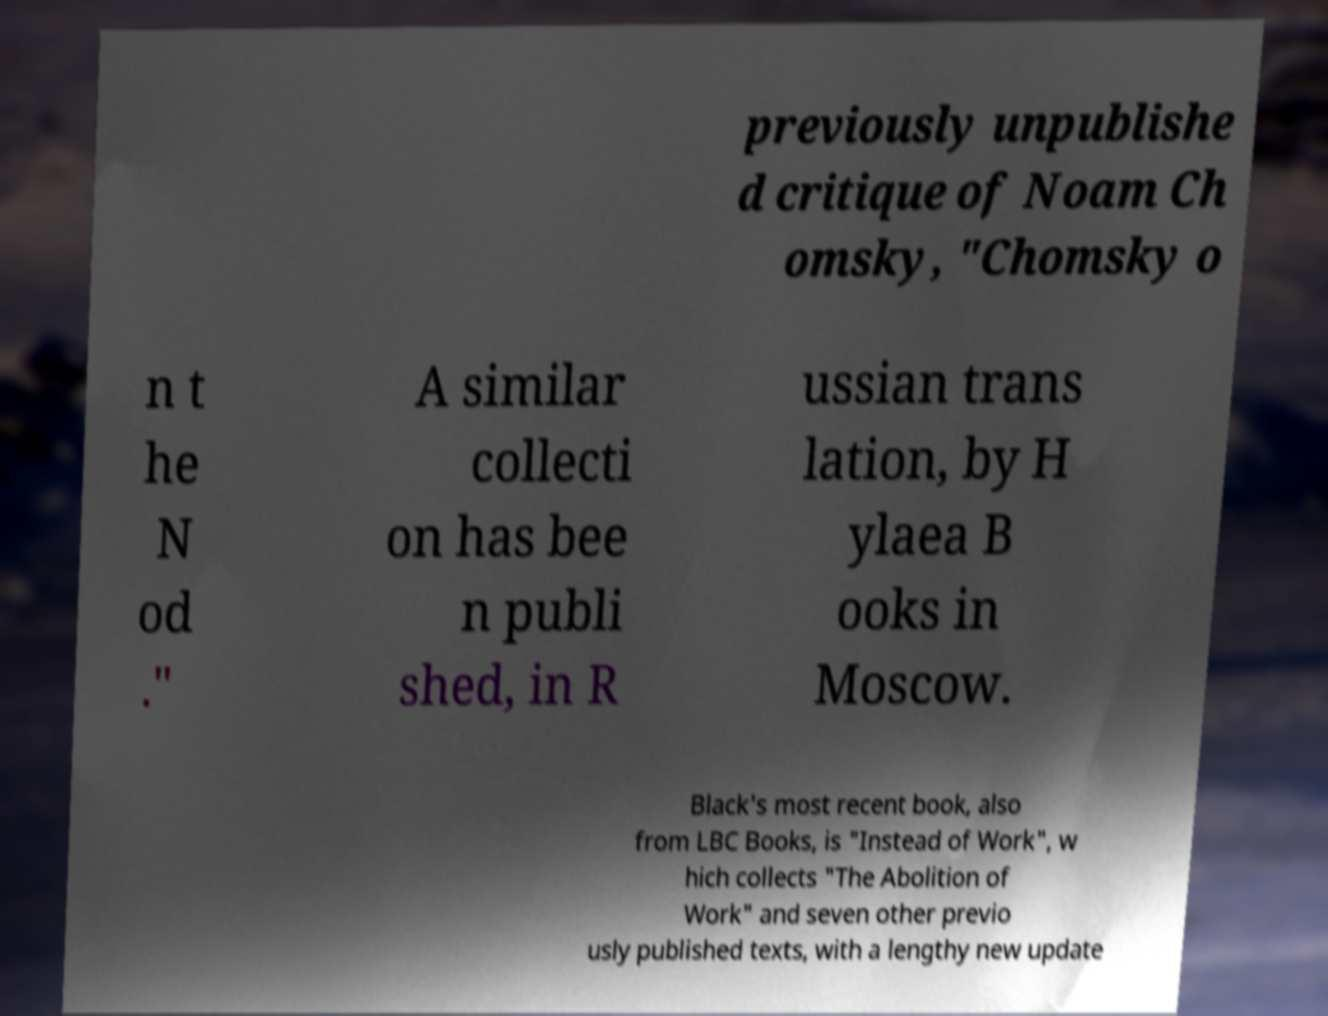For documentation purposes, I need the text within this image transcribed. Could you provide that? previously unpublishe d critique of Noam Ch omsky, "Chomsky o n t he N od ." A similar collecti on has bee n publi shed, in R ussian trans lation, by H ylaea B ooks in Moscow. Black's most recent book, also from LBC Books, is "Instead of Work", w hich collects "The Abolition of Work" and seven other previo usly published texts, with a lengthy new update 